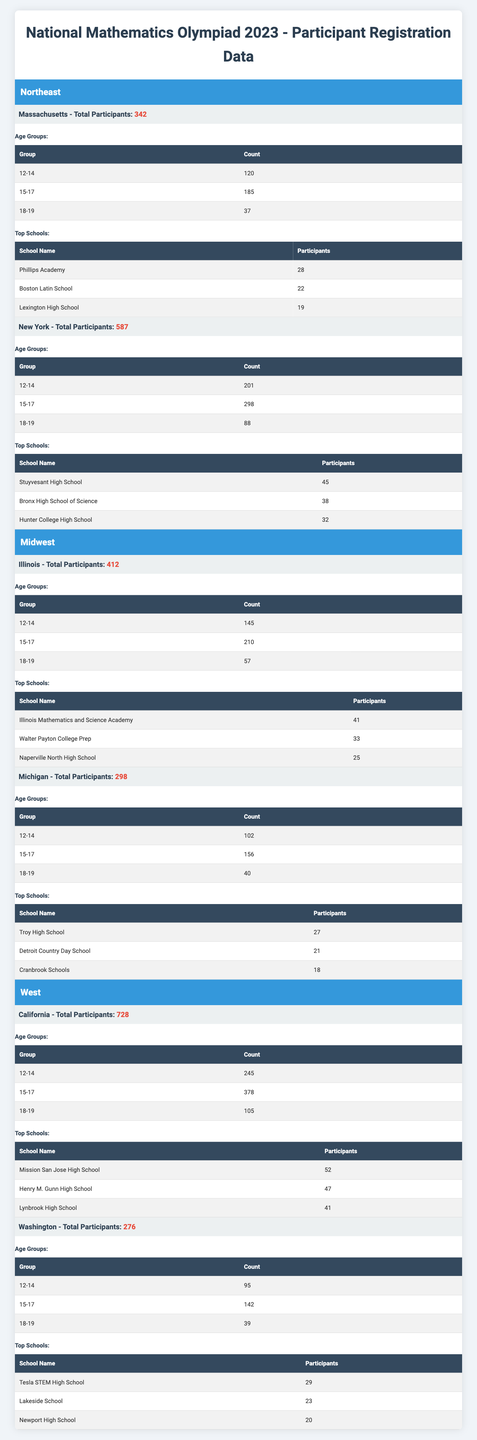What is the total number of participants from Massachusetts? The table shows that Massachusetts has a total of 342 participants, as indicated in the first section under the Northeast region.
Answer: 342 Which age group has the highest number of participants in New York? In New York, the 15-17 age group has 298 participants, which is greater than the other two age groups (12-14 with 201 and 18-19 with 88).
Answer: 15-17 What is the total number of participants in the Midwest region? The total number of participants in the Midwest region is the sum of participants from both Illinois (412) and Michigan (298), which equals 412 + 298 = 710.
Answer: 710 Which state in the West region has the most participants? California has 728 participants, which is more than Washington, which has 276 participants, making California the state with the most participants in the West region.
Answer: California How many participants are in the 12-14 age group across all regions? For the 12-14 age group, we add the counts from each state: Massachusetts (120) + New York (201) + Illinois (145) + Michigan (102) + California (245) + Washington (95) equals a total of 908 participants.
Answer: 908 Does Michigan have more participants than Illinois? Michigan has 298 participants while Illinois has 412 participants. Therefore, Michigan does not have more participants than Illinois.
Answer: No What is the average number of participants per state in the Northeast region? The Northeast region has two states: Massachusetts (342) and New York (587). The average is (342 + 587) / 2 = 464.5 participants per state.
Answer: 464.5 How many more participants does California have compared to Washington? California has 728 participants and Washington has 276 participants. The difference is 728 - 276 = 452 participants.
Answer: 452 What percentage of participants from Illinois fall into the 15-17 age group? In Illinois, there are 210 participants in the 15-17 age group out of a total of 412 participants. The percentage is (210 / 412) * 100 ≈ 51.0%.
Answer: 51.0% Which school has the highest number of participants in the Midwest region? In the Midwest region, Illinois Mathematics and Science Academy has the highest number of participants at 41, compared to the top schools in Michigan.
Answer: Illinois Mathematics and Science Academy 